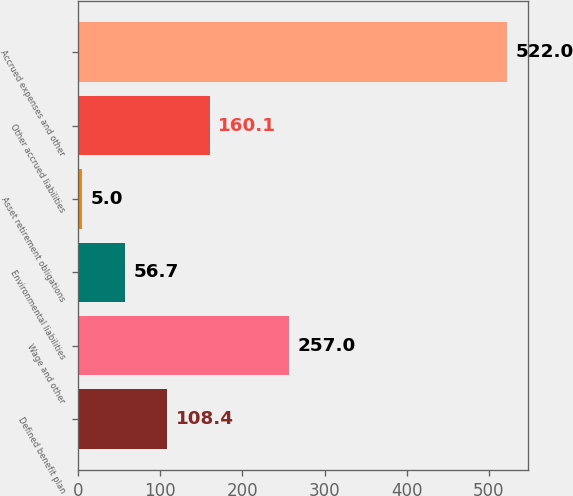<chart> <loc_0><loc_0><loc_500><loc_500><bar_chart><fcel>Defined benefit plan<fcel>Wage and other<fcel>Environmental liabilities<fcel>Asset retirement obligations<fcel>Other accrued liabilities<fcel>Accrued expenses and other<nl><fcel>108.4<fcel>257<fcel>56.7<fcel>5<fcel>160.1<fcel>522<nl></chart> 